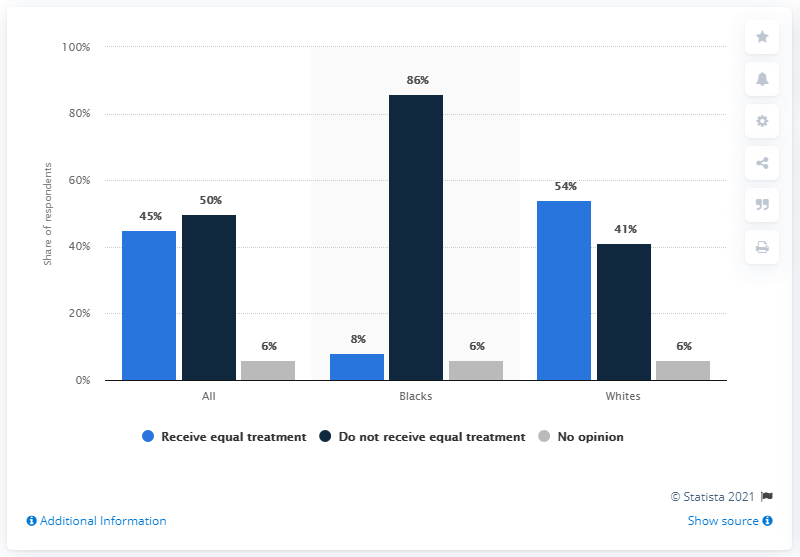Give some essential details in this illustration. According to a recent survey, 86% of Black people do not believe they receive equal treatment. 